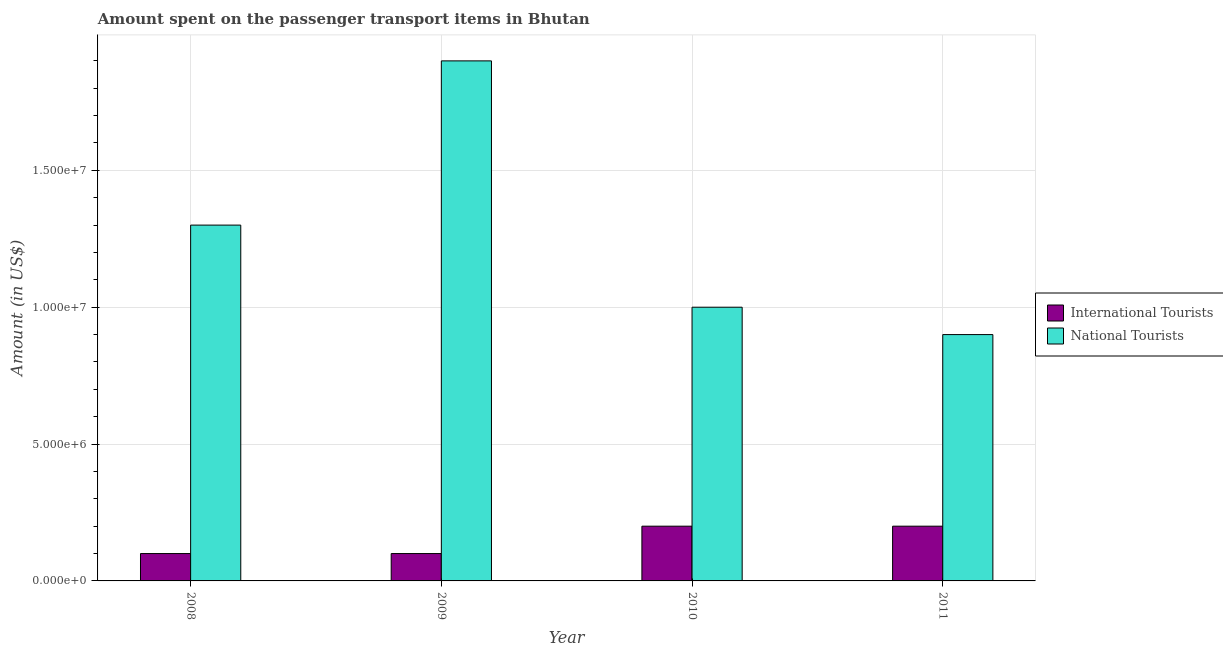Are the number of bars per tick equal to the number of legend labels?
Your response must be concise. Yes. How many bars are there on the 2nd tick from the left?
Your answer should be compact. 2. How many bars are there on the 2nd tick from the right?
Provide a succinct answer. 2. What is the label of the 4th group of bars from the left?
Your response must be concise. 2011. In how many cases, is the number of bars for a given year not equal to the number of legend labels?
Your answer should be very brief. 0. What is the amount spent on transport items of international tourists in 2009?
Give a very brief answer. 1.00e+06. Across all years, what is the maximum amount spent on transport items of national tourists?
Keep it short and to the point. 1.90e+07. Across all years, what is the minimum amount spent on transport items of national tourists?
Give a very brief answer. 9.00e+06. In which year was the amount spent on transport items of national tourists minimum?
Make the answer very short. 2011. What is the total amount spent on transport items of national tourists in the graph?
Give a very brief answer. 5.10e+07. What is the difference between the amount spent on transport items of national tourists in 2008 and that in 2011?
Provide a succinct answer. 4.00e+06. What is the difference between the amount spent on transport items of international tourists in 2011 and the amount spent on transport items of national tourists in 2008?
Offer a very short reply. 1.00e+06. What is the average amount spent on transport items of international tourists per year?
Your answer should be very brief. 1.50e+06. In the year 2010, what is the difference between the amount spent on transport items of international tourists and amount spent on transport items of national tourists?
Offer a terse response. 0. In how many years, is the amount spent on transport items of international tourists greater than 14000000 US$?
Provide a succinct answer. 0. What is the ratio of the amount spent on transport items of national tourists in 2010 to that in 2011?
Provide a succinct answer. 1.11. Is the amount spent on transport items of international tourists in 2008 less than that in 2010?
Your response must be concise. Yes. Is the difference between the amount spent on transport items of international tourists in 2008 and 2009 greater than the difference between the amount spent on transport items of national tourists in 2008 and 2009?
Provide a succinct answer. No. What is the difference between the highest and the second highest amount spent on transport items of international tourists?
Your answer should be compact. 0. What is the difference between the highest and the lowest amount spent on transport items of international tourists?
Offer a very short reply. 1.00e+06. What does the 1st bar from the left in 2008 represents?
Keep it short and to the point. International Tourists. What does the 2nd bar from the right in 2009 represents?
Make the answer very short. International Tourists. How many years are there in the graph?
Offer a terse response. 4. Does the graph contain any zero values?
Your answer should be compact. No. Where does the legend appear in the graph?
Make the answer very short. Center right. How are the legend labels stacked?
Provide a short and direct response. Vertical. What is the title of the graph?
Offer a terse response. Amount spent on the passenger transport items in Bhutan. What is the label or title of the Y-axis?
Keep it short and to the point. Amount (in US$). What is the Amount (in US$) in International Tourists in 2008?
Your answer should be very brief. 1.00e+06. What is the Amount (in US$) of National Tourists in 2008?
Keep it short and to the point. 1.30e+07. What is the Amount (in US$) of International Tourists in 2009?
Offer a very short reply. 1.00e+06. What is the Amount (in US$) in National Tourists in 2009?
Your answer should be compact. 1.90e+07. What is the Amount (in US$) in National Tourists in 2010?
Provide a succinct answer. 1.00e+07. What is the Amount (in US$) of International Tourists in 2011?
Keep it short and to the point. 2.00e+06. What is the Amount (in US$) of National Tourists in 2011?
Your answer should be very brief. 9.00e+06. Across all years, what is the maximum Amount (in US$) of National Tourists?
Your answer should be compact. 1.90e+07. Across all years, what is the minimum Amount (in US$) in National Tourists?
Your response must be concise. 9.00e+06. What is the total Amount (in US$) of National Tourists in the graph?
Provide a short and direct response. 5.10e+07. What is the difference between the Amount (in US$) in International Tourists in 2008 and that in 2009?
Ensure brevity in your answer.  0. What is the difference between the Amount (in US$) of National Tourists in 2008 and that in 2009?
Offer a very short reply. -6.00e+06. What is the difference between the Amount (in US$) in National Tourists in 2008 and that in 2010?
Your answer should be very brief. 3.00e+06. What is the difference between the Amount (in US$) in International Tourists in 2008 and that in 2011?
Keep it short and to the point. -1.00e+06. What is the difference between the Amount (in US$) of National Tourists in 2008 and that in 2011?
Provide a succinct answer. 4.00e+06. What is the difference between the Amount (in US$) in National Tourists in 2009 and that in 2010?
Give a very brief answer. 9.00e+06. What is the difference between the Amount (in US$) in International Tourists in 2010 and that in 2011?
Your answer should be compact. 0. What is the difference between the Amount (in US$) in National Tourists in 2010 and that in 2011?
Provide a succinct answer. 1.00e+06. What is the difference between the Amount (in US$) in International Tourists in 2008 and the Amount (in US$) in National Tourists in 2009?
Give a very brief answer. -1.80e+07. What is the difference between the Amount (in US$) of International Tourists in 2008 and the Amount (in US$) of National Tourists in 2010?
Offer a terse response. -9.00e+06. What is the difference between the Amount (in US$) in International Tourists in 2008 and the Amount (in US$) in National Tourists in 2011?
Provide a short and direct response. -8.00e+06. What is the difference between the Amount (in US$) in International Tourists in 2009 and the Amount (in US$) in National Tourists in 2010?
Ensure brevity in your answer.  -9.00e+06. What is the difference between the Amount (in US$) of International Tourists in 2009 and the Amount (in US$) of National Tourists in 2011?
Your response must be concise. -8.00e+06. What is the difference between the Amount (in US$) of International Tourists in 2010 and the Amount (in US$) of National Tourists in 2011?
Offer a terse response. -7.00e+06. What is the average Amount (in US$) in International Tourists per year?
Make the answer very short. 1.50e+06. What is the average Amount (in US$) of National Tourists per year?
Your answer should be very brief. 1.28e+07. In the year 2008, what is the difference between the Amount (in US$) in International Tourists and Amount (in US$) in National Tourists?
Keep it short and to the point. -1.20e+07. In the year 2009, what is the difference between the Amount (in US$) of International Tourists and Amount (in US$) of National Tourists?
Give a very brief answer. -1.80e+07. In the year 2010, what is the difference between the Amount (in US$) of International Tourists and Amount (in US$) of National Tourists?
Your response must be concise. -8.00e+06. In the year 2011, what is the difference between the Amount (in US$) of International Tourists and Amount (in US$) of National Tourists?
Your answer should be very brief. -7.00e+06. What is the ratio of the Amount (in US$) in International Tourists in 2008 to that in 2009?
Provide a short and direct response. 1. What is the ratio of the Amount (in US$) in National Tourists in 2008 to that in 2009?
Make the answer very short. 0.68. What is the ratio of the Amount (in US$) in International Tourists in 2008 to that in 2010?
Your answer should be compact. 0.5. What is the ratio of the Amount (in US$) in International Tourists in 2008 to that in 2011?
Offer a terse response. 0.5. What is the ratio of the Amount (in US$) of National Tourists in 2008 to that in 2011?
Provide a short and direct response. 1.44. What is the ratio of the Amount (in US$) in National Tourists in 2009 to that in 2011?
Your response must be concise. 2.11. What is the ratio of the Amount (in US$) of International Tourists in 2010 to that in 2011?
Ensure brevity in your answer.  1. What is the ratio of the Amount (in US$) of National Tourists in 2010 to that in 2011?
Provide a short and direct response. 1.11. 